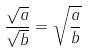Convert formula to latex. <formula><loc_0><loc_0><loc_500><loc_500>\frac { \sqrt { a } } { \sqrt { b } } = \sqrt { \frac { a } { b } }</formula> 